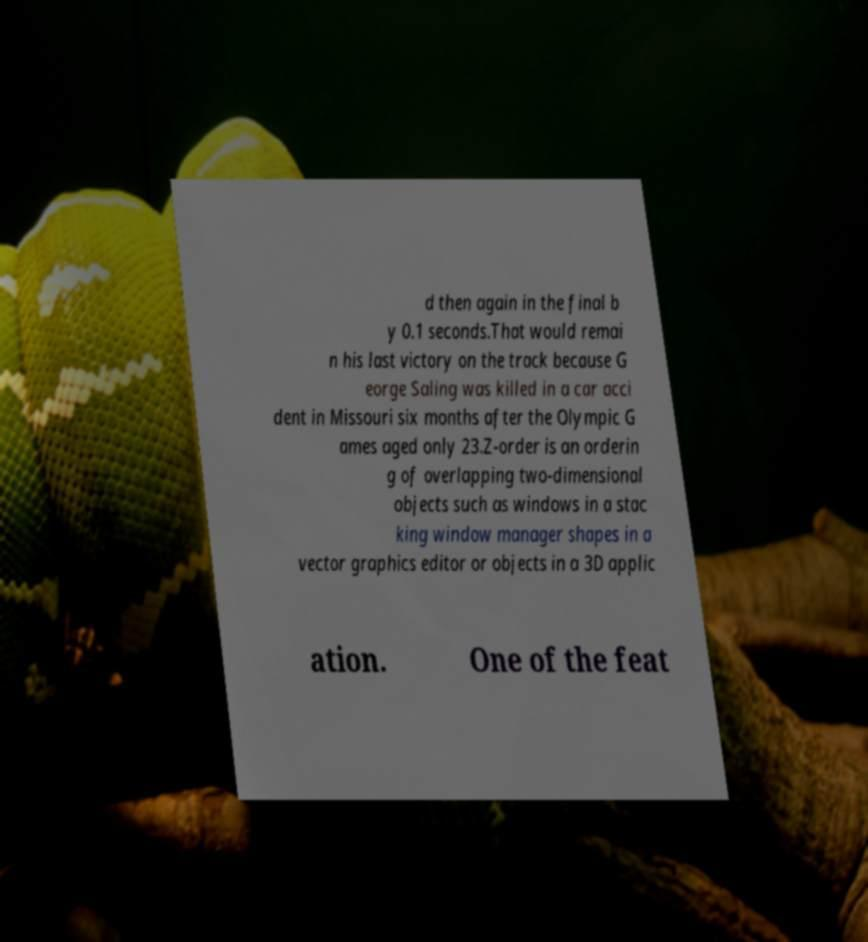Could you extract and type out the text from this image? d then again in the final b y 0.1 seconds.That would remai n his last victory on the track because G eorge Saling was killed in a car acci dent in Missouri six months after the Olympic G ames aged only 23.Z-order is an orderin g of overlapping two-dimensional objects such as windows in a stac king window manager shapes in a vector graphics editor or objects in a 3D applic ation. One of the feat 